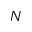Convert formula to latex. <formula><loc_0><loc_0><loc_500><loc_500>N</formula> 